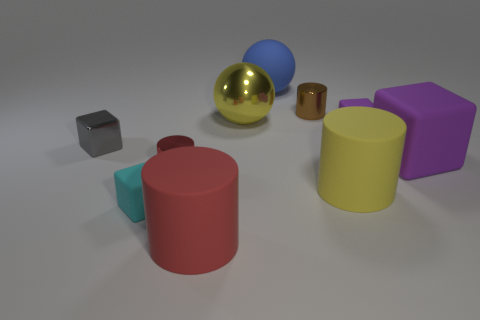Are there the same number of yellow things to the right of the yellow matte cylinder and yellow objects that are in front of the tiny cyan thing?
Provide a short and direct response. Yes. There is a blue matte thing; does it have the same size as the rubber cube in front of the red metallic thing?
Keep it short and to the point. No. Are there more small purple matte things that are on the left side of the tiny gray metallic block than gray rubber cubes?
Your response must be concise. No. How many cyan things are the same size as the blue rubber object?
Your answer should be very brief. 0. There is a red cylinder in front of the small cyan rubber block; is it the same size as the ball that is behind the brown shiny object?
Offer a very short reply. Yes. Is the number of large blue things that are to the left of the tiny gray object greater than the number of matte blocks on the left side of the large blue thing?
Make the answer very short. No. What number of other tiny rubber objects have the same shape as the cyan thing?
Your answer should be compact. 1. There is a red cylinder that is the same size as the brown metallic object; what is its material?
Your response must be concise. Metal. Are there any yellow things made of the same material as the tiny purple block?
Offer a terse response. Yes. Is the number of yellow rubber cylinders behind the red shiny cylinder less than the number of large spheres?
Make the answer very short. Yes. 